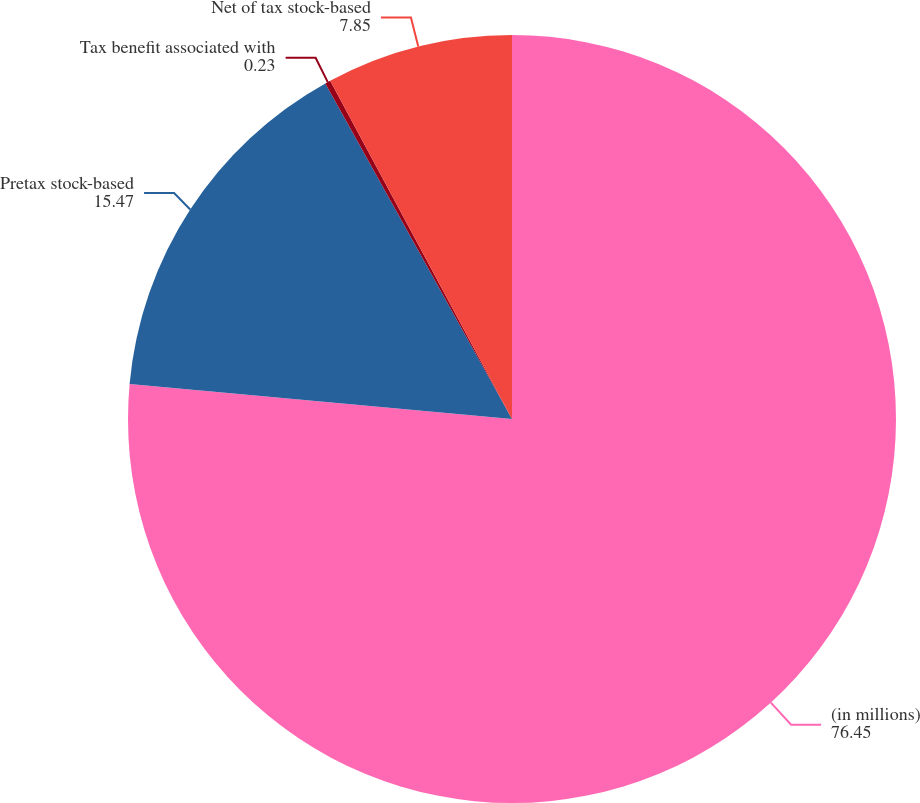<chart> <loc_0><loc_0><loc_500><loc_500><pie_chart><fcel>(in millions)<fcel>Pretax stock-based<fcel>Tax benefit associated with<fcel>Net of tax stock-based<nl><fcel>76.45%<fcel>15.47%<fcel>0.23%<fcel>7.85%<nl></chart> 